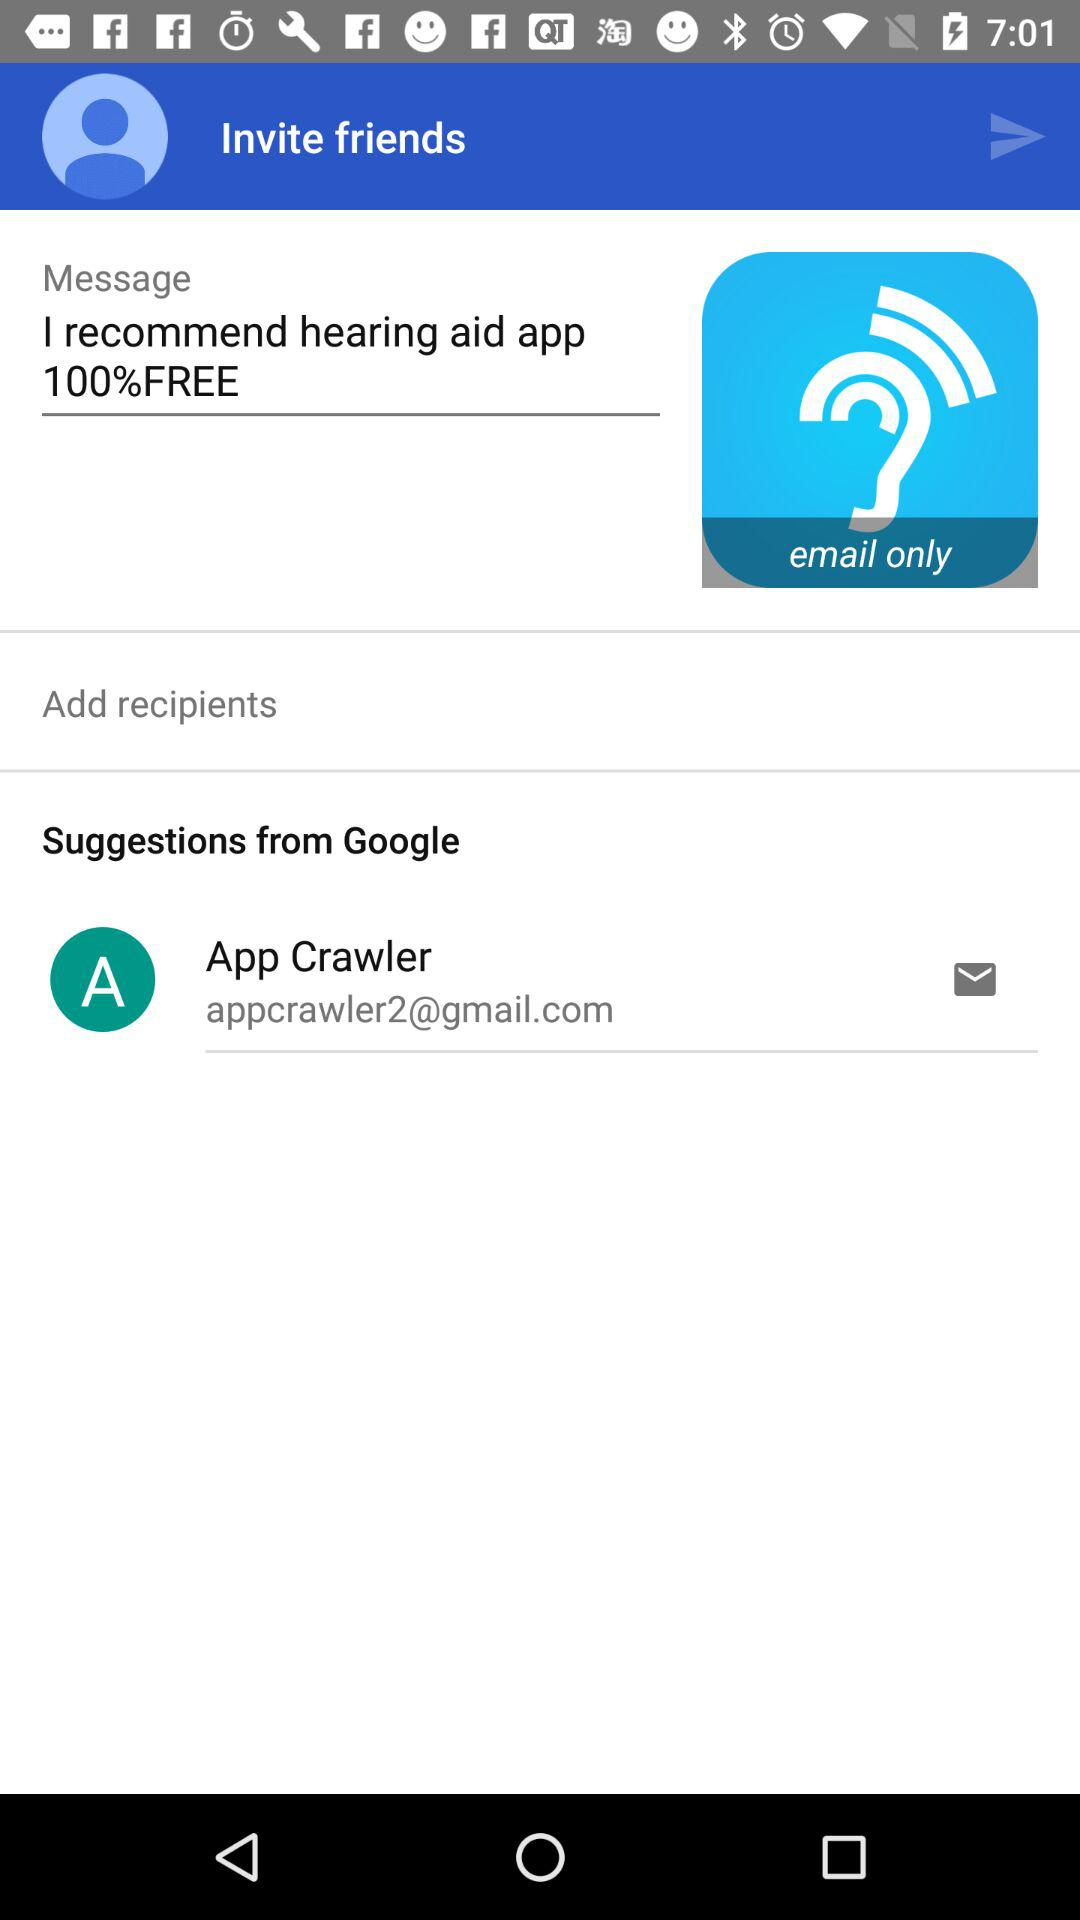What is the email address of the user? The email address of the user is appcrawler2@gmail.com. 